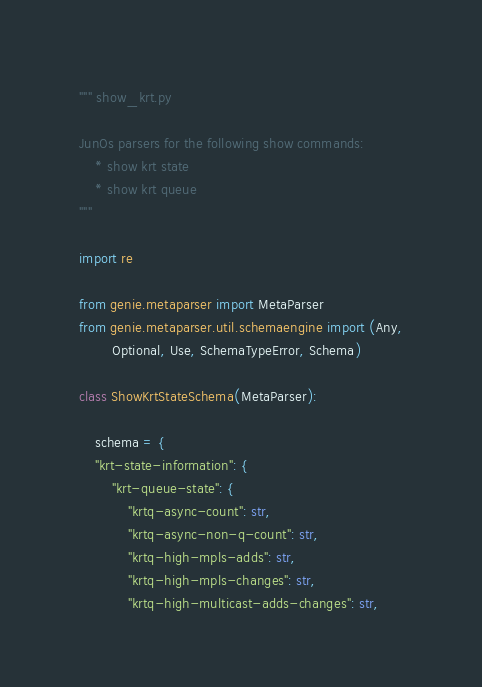Convert code to text. <code><loc_0><loc_0><loc_500><loc_500><_Python_>""" show_krt.py

JunOs parsers for the following show commands:
    * show krt state
    * show krt queue
"""

import re

from genie.metaparser import MetaParser
from genie.metaparser.util.schemaengine import (Any,
        Optional, Use, SchemaTypeError, Schema)

class ShowKrtStateSchema(MetaParser):

    schema = {
    "krt-state-information": {
        "krt-queue-state": {
            "krtq-async-count": str,
            "krtq-async-non-q-count": str,
            "krtq-high-mpls-adds": str,
            "krtq-high-mpls-changes": str,
            "krtq-high-multicast-adds-changes": str,</code> 